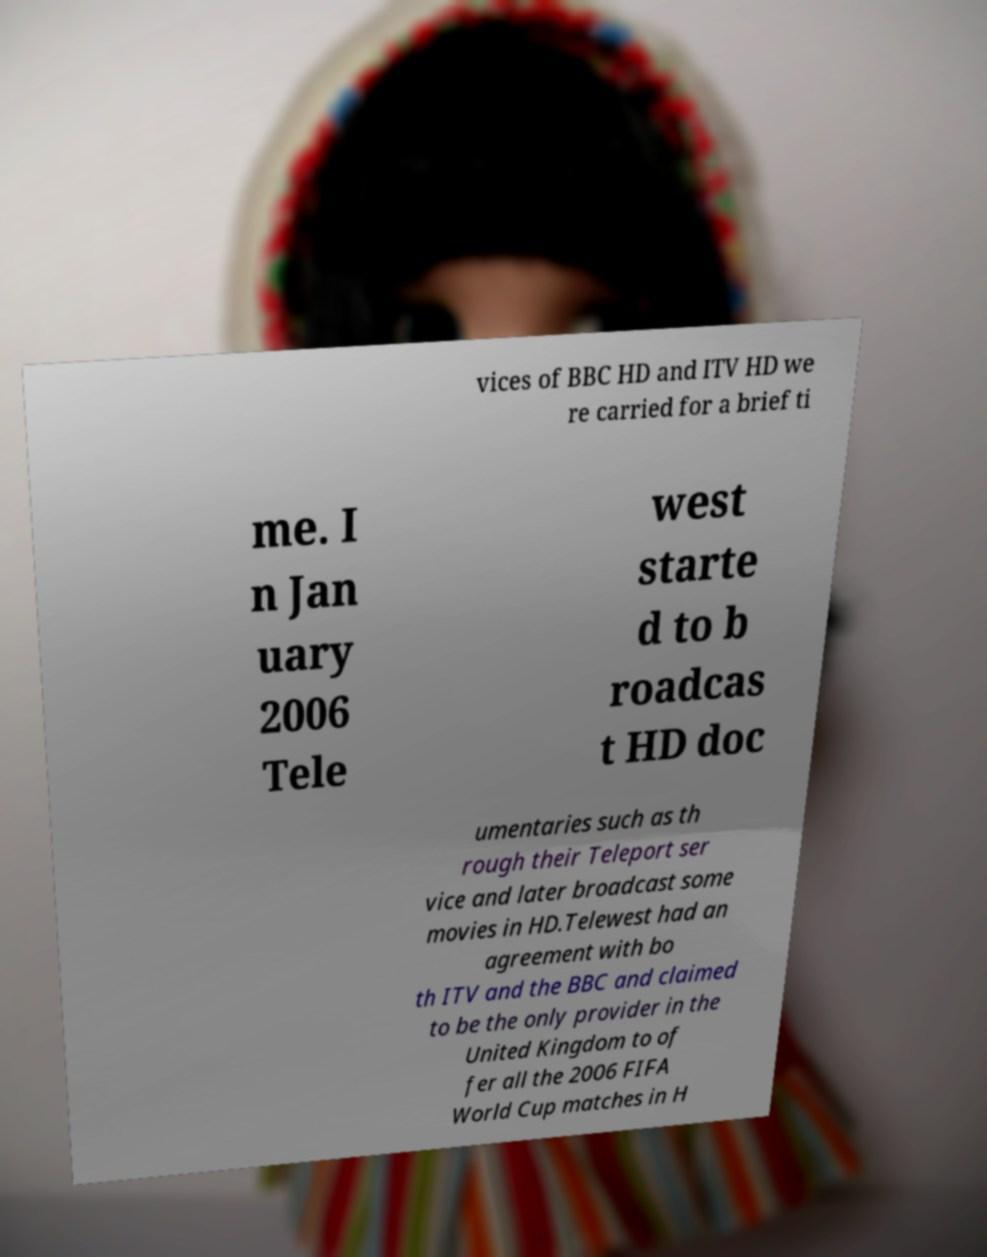I need the written content from this picture converted into text. Can you do that? vices of BBC HD and ITV HD we re carried for a brief ti me. I n Jan uary 2006 Tele west starte d to b roadcas t HD doc umentaries such as th rough their Teleport ser vice and later broadcast some movies in HD.Telewest had an agreement with bo th ITV and the BBC and claimed to be the only provider in the United Kingdom to of fer all the 2006 FIFA World Cup matches in H 